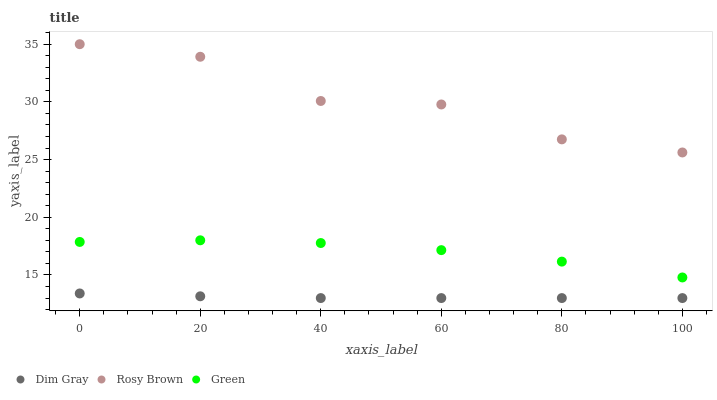Does Dim Gray have the minimum area under the curve?
Answer yes or no. Yes. Does Rosy Brown have the maximum area under the curve?
Answer yes or no. Yes. Does Green have the minimum area under the curve?
Answer yes or no. No. Does Green have the maximum area under the curve?
Answer yes or no. No. Is Dim Gray the smoothest?
Answer yes or no. Yes. Is Rosy Brown the roughest?
Answer yes or no. Yes. Is Green the smoothest?
Answer yes or no. No. Is Green the roughest?
Answer yes or no. No. Does Dim Gray have the lowest value?
Answer yes or no. Yes. Does Green have the lowest value?
Answer yes or no. No. Does Rosy Brown have the highest value?
Answer yes or no. Yes. Does Green have the highest value?
Answer yes or no. No. Is Green less than Rosy Brown?
Answer yes or no. Yes. Is Rosy Brown greater than Green?
Answer yes or no. Yes. Does Green intersect Rosy Brown?
Answer yes or no. No. 